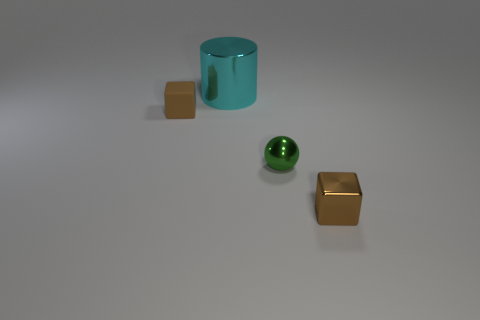What color is the thing that is to the left of the large cyan shiny cylinder?
Keep it short and to the point. Brown. Is there a matte object to the right of the brown block to the right of the tiny metal ball?
Give a very brief answer. No. Is the color of the tiny object right of the green ball the same as the block on the left side of the metal cube?
Your answer should be very brief. Yes. There is a large metal object; how many objects are behind it?
Keep it short and to the point. 0. How many spheres are the same color as the big shiny cylinder?
Give a very brief answer. 0. Are there the same number of tiny brown rubber objects and small brown blocks?
Give a very brief answer. No. Is the material of the tiny brown thing right of the cyan shiny thing the same as the tiny green sphere?
Your response must be concise. Yes. How many cyan cylinders are made of the same material as the tiny green thing?
Your answer should be compact. 1. Are there more metal blocks behind the small green metal thing than large objects?
Your response must be concise. No. There is a thing that is the same color as the rubber block; what is its size?
Your response must be concise. Small. 